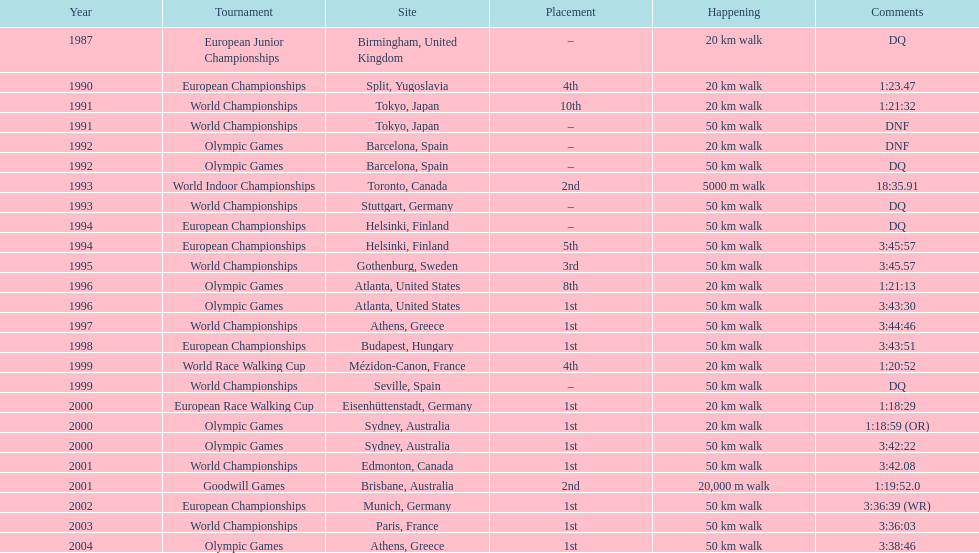How many times was first place listed as the position? 10. 